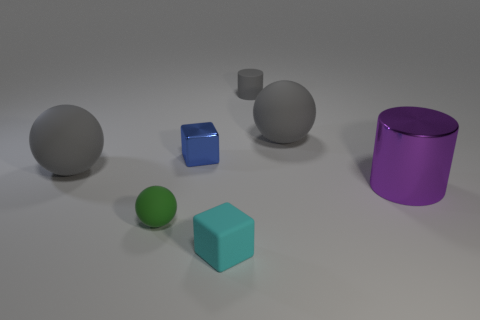What size is the gray rubber object on the left side of the small matte cylinder that is behind the tiny metal thing?
Provide a succinct answer. Large. Do the large rubber thing that is in front of the small blue metallic thing and the cylinder that is behind the large cylinder have the same color?
Keep it short and to the point. Yes. How many blue objects are either small matte cylinders or cylinders?
Give a very brief answer. 0. What number of blocks are the same size as the cyan object?
Provide a succinct answer. 1. Is the material of the gray thing left of the blue thing the same as the tiny green thing?
Offer a very short reply. Yes. There is a matte sphere on the left side of the green rubber object; are there any rubber cylinders left of it?
Provide a short and direct response. No. There is a blue object that is the same shape as the small cyan object; what material is it?
Offer a terse response. Metal. Is the number of gray rubber things that are behind the metal cylinder greater than the number of green matte objects that are on the left side of the blue thing?
Provide a succinct answer. Yes. What is the shape of the cyan object that is made of the same material as the tiny green object?
Make the answer very short. Cube. Is the number of large gray rubber objects to the right of the small cyan matte thing greater than the number of cyan rubber spheres?
Make the answer very short. Yes. 